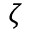Convert formula to latex. <formula><loc_0><loc_0><loc_500><loc_500>\zeta</formula> 